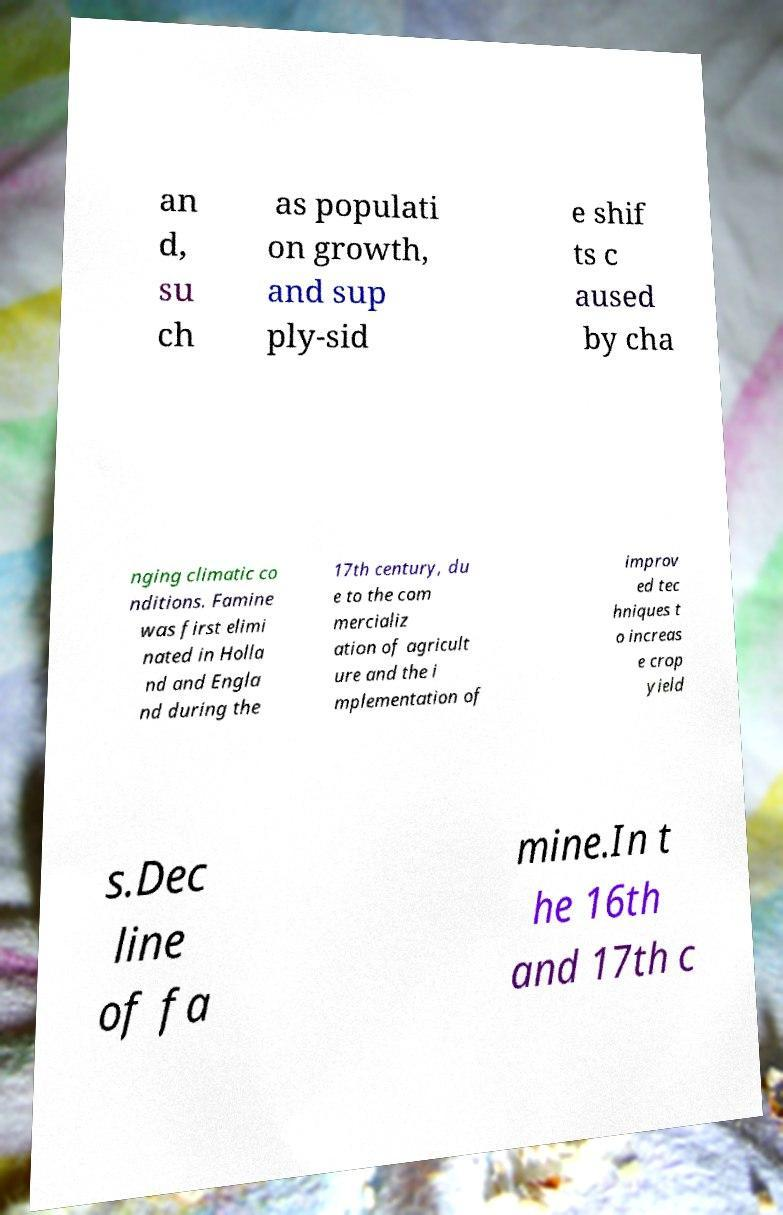Could you extract and type out the text from this image? an d, su ch as populati on growth, and sup ply-sid e shif ts c aused by cha nging climatic co nditions. Famine was first elimi nated in Holla nd and Engla nd during the 17th century, du e to the com mercializ ation of agricult ure and the i mplementation of improv ed tec hniques t o increas e crop yield s.Dec line of fa mine.In t he 16th and 17th c 